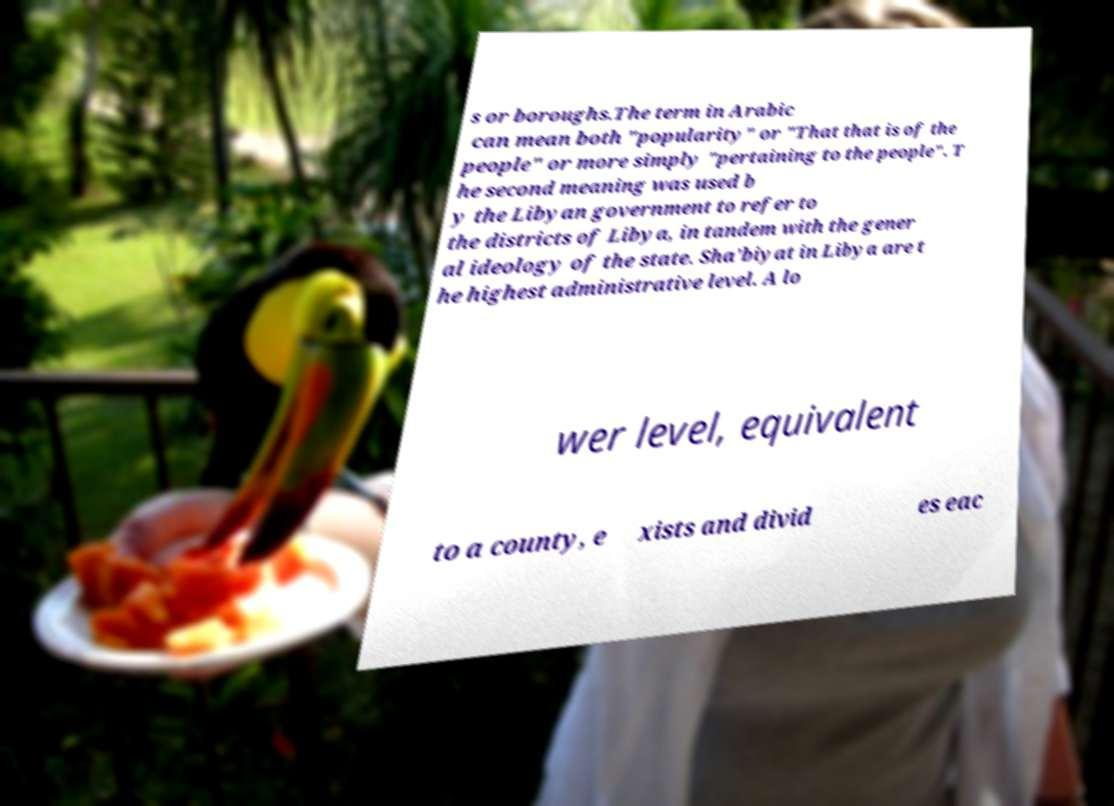Please identify and transcribe the text found in this image. s or boroughs.The term in Arabic can mean both "popularity" or "That that is of the people" or more simply "pertaining to the people". T he second meaning was used b y the Libyan government to refer to the districts of Libya, in tandem with the gener al ideology of the state. Sha'biyat in Libya are t he highest administrative level. A lo wer level, equivalent to a county, e xists and divid es eac 